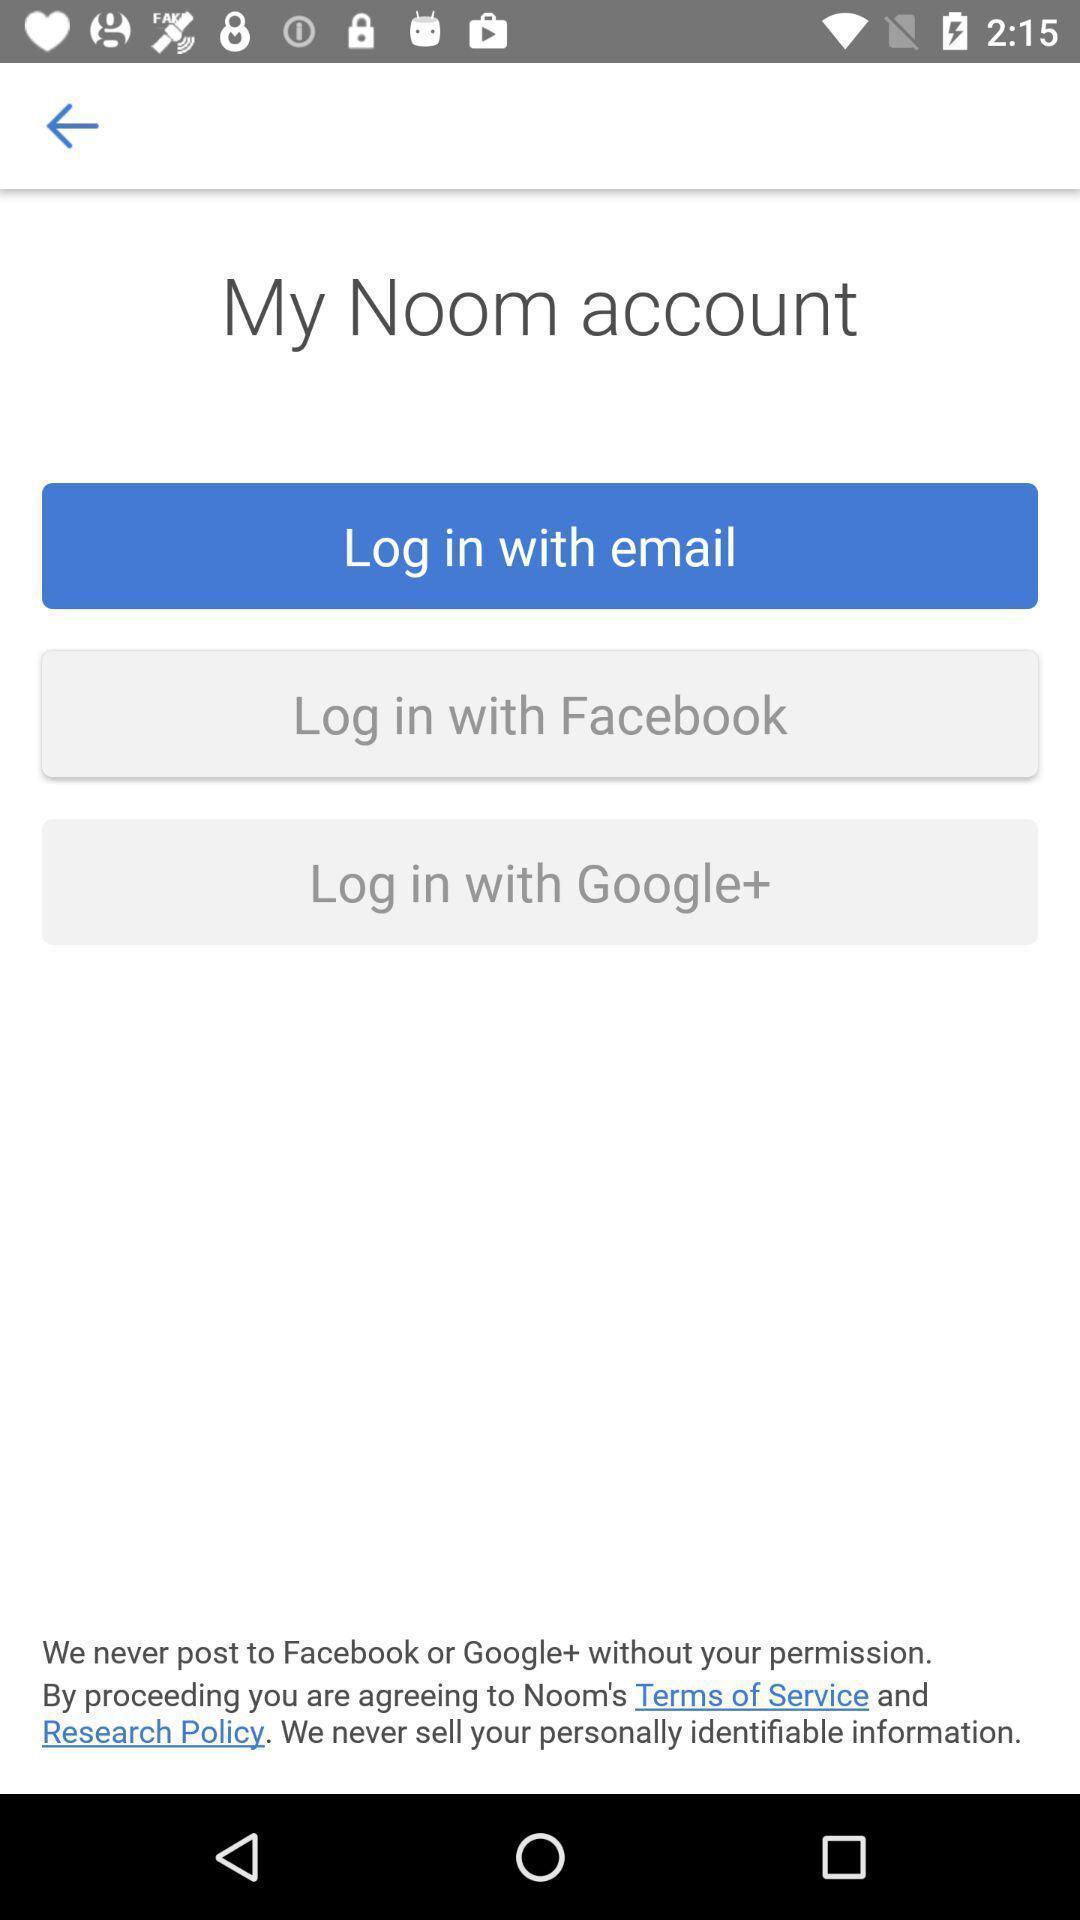Explain the elements present in this screenshot. Multiple login options for a healthcare app. 